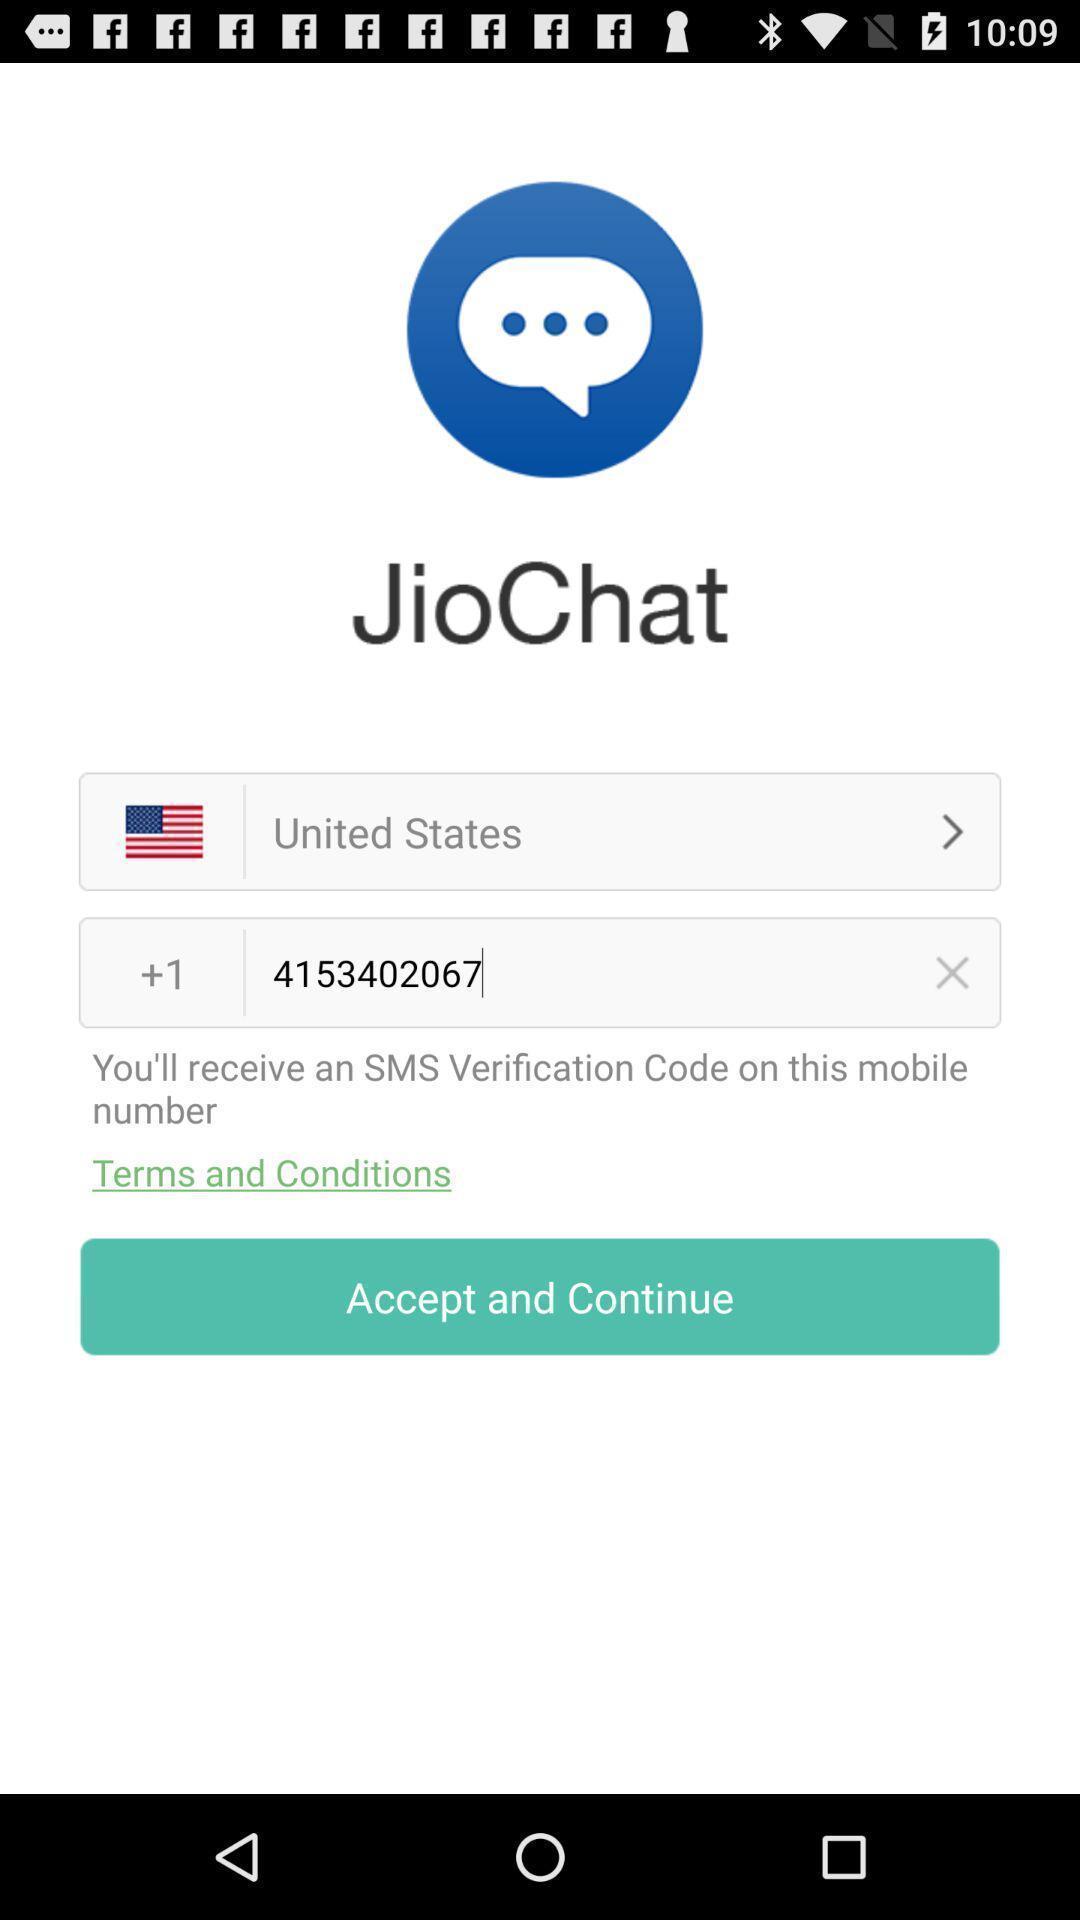Summarize the main components in this picture. Welcome page of a messaging application. 